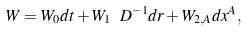<formula> <loc_0><loc_0><loc_500><loc_500>W = W _ { 0 } d t + W _ { 1 } \ D ^ { - 1 } d r + W _ { 2 , A } d x ^ { A } ,</formula> 